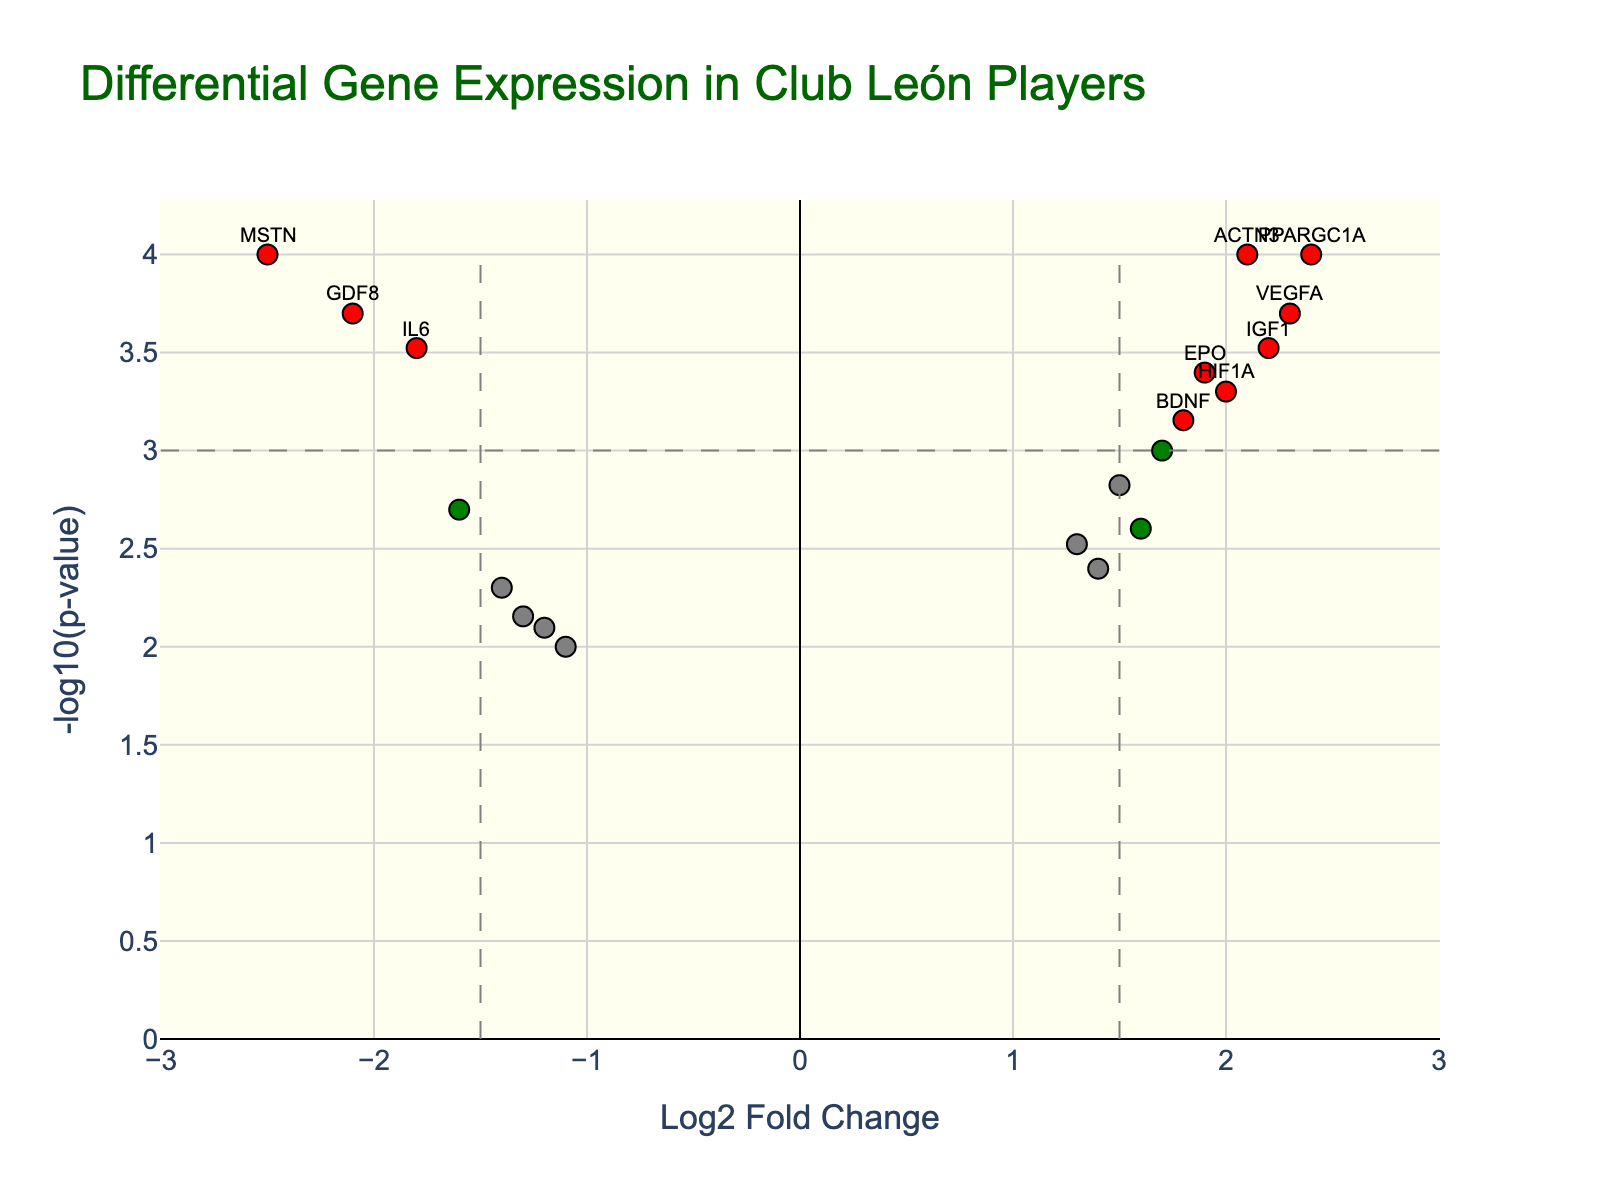What does the title of the plot indicate about the study? The title "Differential Gene Expression in Club León Players" suggests that the plot presents gene expression differences between Club León football players and the average Mexican population.
Answer: Differential Gene Expression in Club León Players What do the colors of the data points indicate? The colors indicate significance and the direction of gene expression changes. Red points are significantly changed genes with high fold change and low p-value, blue points are significant but with lower fold change, and green points are less significant but with high fold change.
Answer: Significance and direction of changes How many genes are labelled on the plot, and why? There are five genes labelled: ACTN3, PPARA, VEGFA, IGF1, and MSTN; these are the genes with significant changes having both a high fold change and low p-value.
Answer: Five genes What does a red data point represent? A red data point represents a gene with both a significant log2 fold change (greater than 1.5 or less than -1.5) and a significant p-value (less than 0.001).
Answer: Significant fold change and p-value Which gene has the highest log2 fold change? The gene with the highest log2 fold change is PPARGC1A with a value of 2.4.
Answer: PPARGC1A What is the log2 fold change and p-value for MSTN, and what is their significance? MSTN has a log2 fold change of -2.5 and a very low p-value of 0.0001, making it a significant down-regulated gene in the players.
Answer: -2.5 log2 fold change, 0.0001 p-value Which genes are up-regulated and are labeled on the plot? The labeled up-regulated genes are ACTN3, PPARA, VEGFA, and IGF1.
Answer: ACTN3, PPARA, VEGFA, IGF1 Compare the log2 fold changes and p-values for HIF1A and IL6. Which gene is more significantly changed? HIF1A has a log2 fold change of 2.0 and a p-value of 0.0005. IL6 has a log2 fold change of -1.8 and a p-value of 0.0003. By comparing the p-values, IL6 is slightly more significantly changed because its p-value is lower.
Answer: IL6 is more significantly changed How would you describe the gene expression pattern for ADRB2 in terms of fold change and statistical significance? ADRB2 has a log2 fold change of 1.3 and a p-value of 0.0030. It shows moderate up-regulation but is less statistically significant compared to the genes in red.
Answer: Moderate up-regulation, less significant 